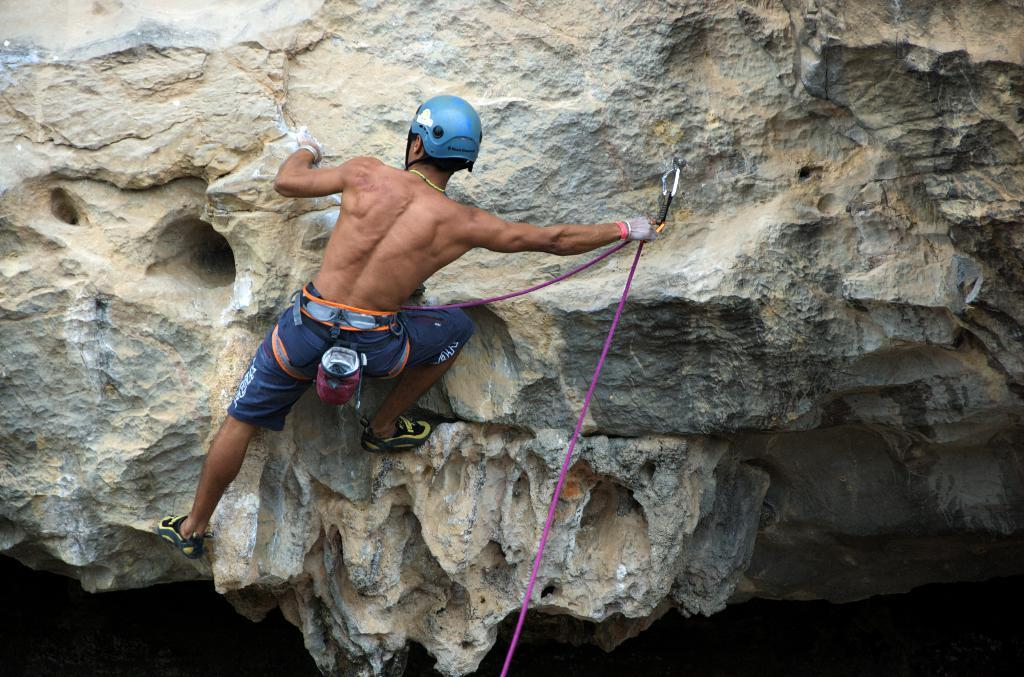What is the main subject of the image? There is a person in the image. What is the person doing in the image? The person is climbing on a rock. What type of coil can be seen in the image? There is no coil present in the image; it features a person climbing on a rock. What kind of playground equipment can be seen in the image? There is no playground equipment present in the image; it features a person climbing on a rock. 